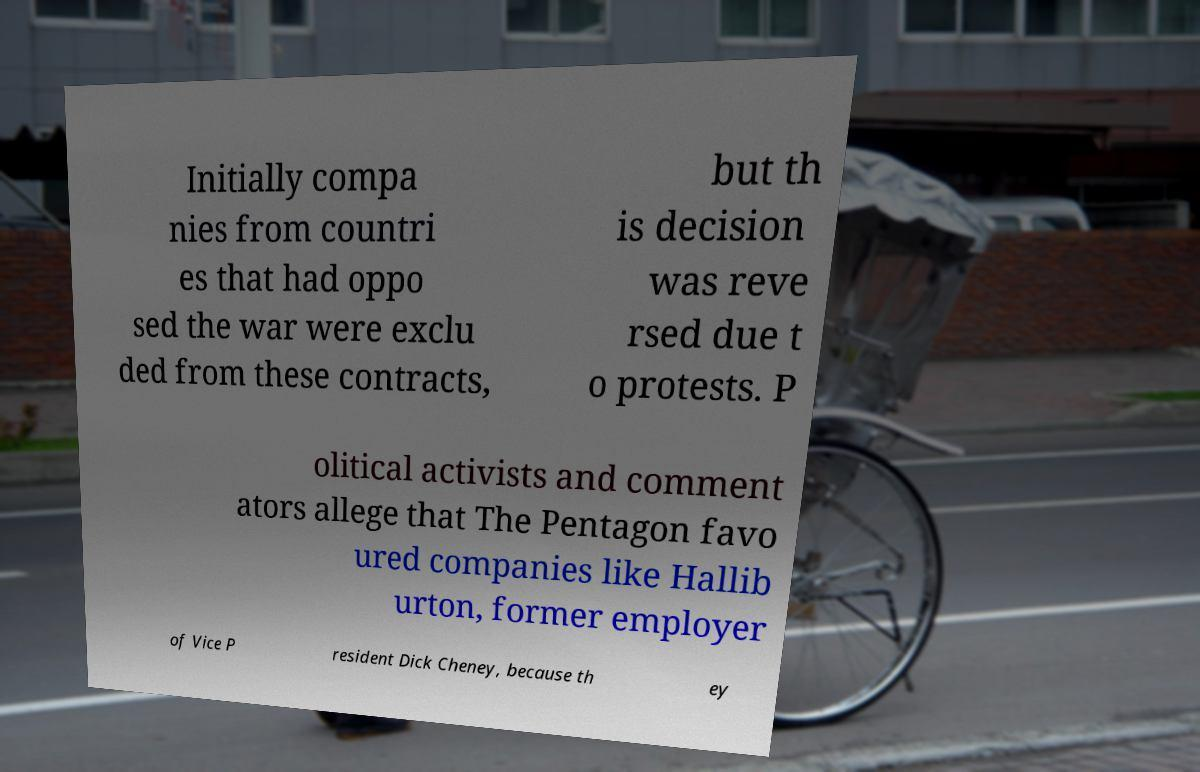There's text embedded in this image that I need extracted. Can you transcribe it verbatim? Initially compa nies from countri es that had oppo sed the war were exclu ded from these contracts, but th is decision was reve rsed due t o protests. P olitical activists and comment ators allege that The Pentagon favo ured companies like Hallib urton, former employer of Vice P resident Dick Cheney, because th ey 